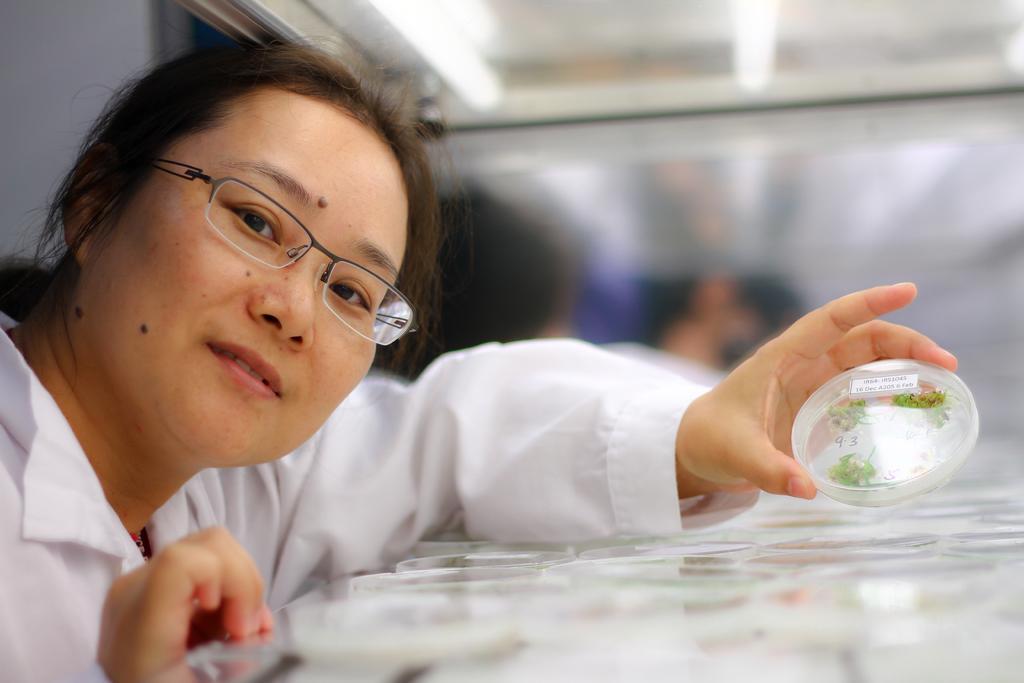How would you summarize this image in a sentence or two? This image consists of a woman wearing a white dress. And she is holding a small box. In which we can see small leaves. The background is blurred. 